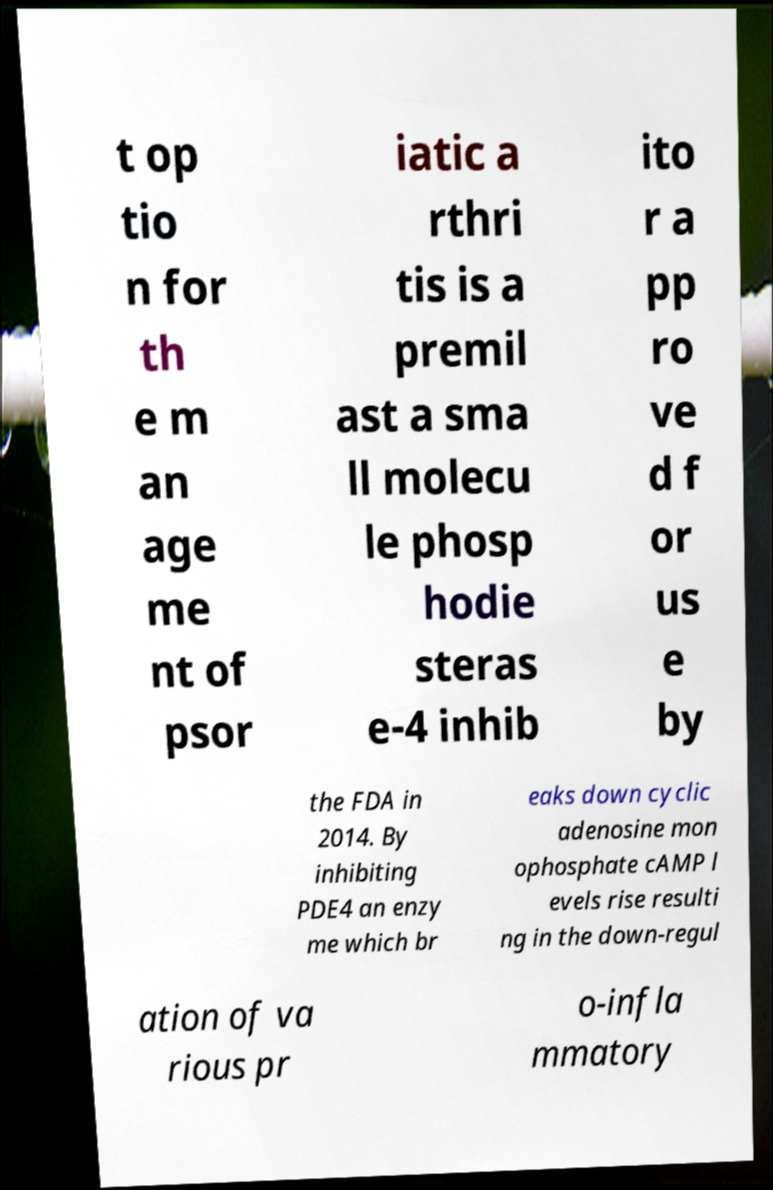Could you assist in decoding the text presented in this image and type it out clearly? t op tio n for th e m an age me nt of psor iatic a rthri tis is a premil ast a sma ll molecu le phosp hodie steras e-4 inhib ito r a pp ro ve d f or us e by the FDA in 2014. By inhibiting PDE4 an enzy me which br eaks down cyclic adenosine mon ophosphate cAMP l evels rise resulti ng in the down-regul ation of va rious pr o-infla mmatory 